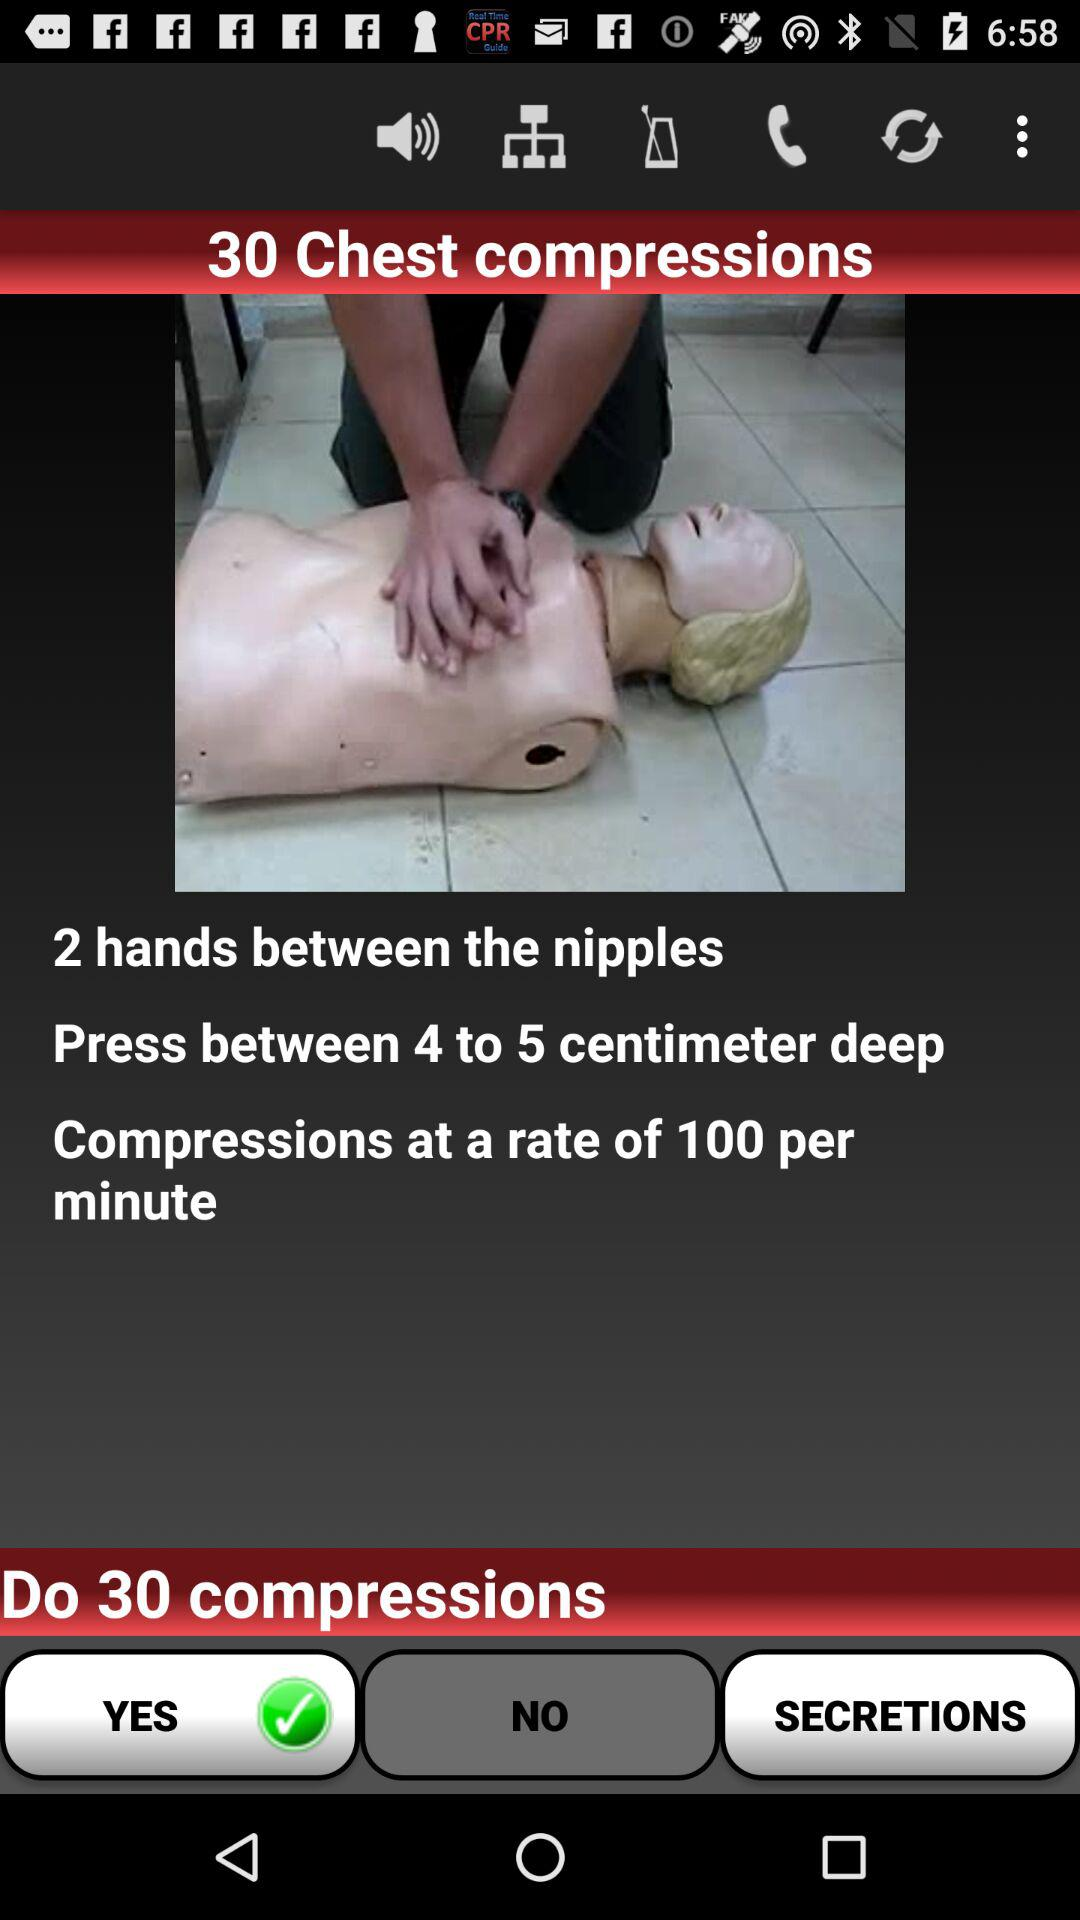What should be the depth of pressing the chest in the compression process? The depth of pressing the chest in the compression process should be 4 to 5 centimeters. 